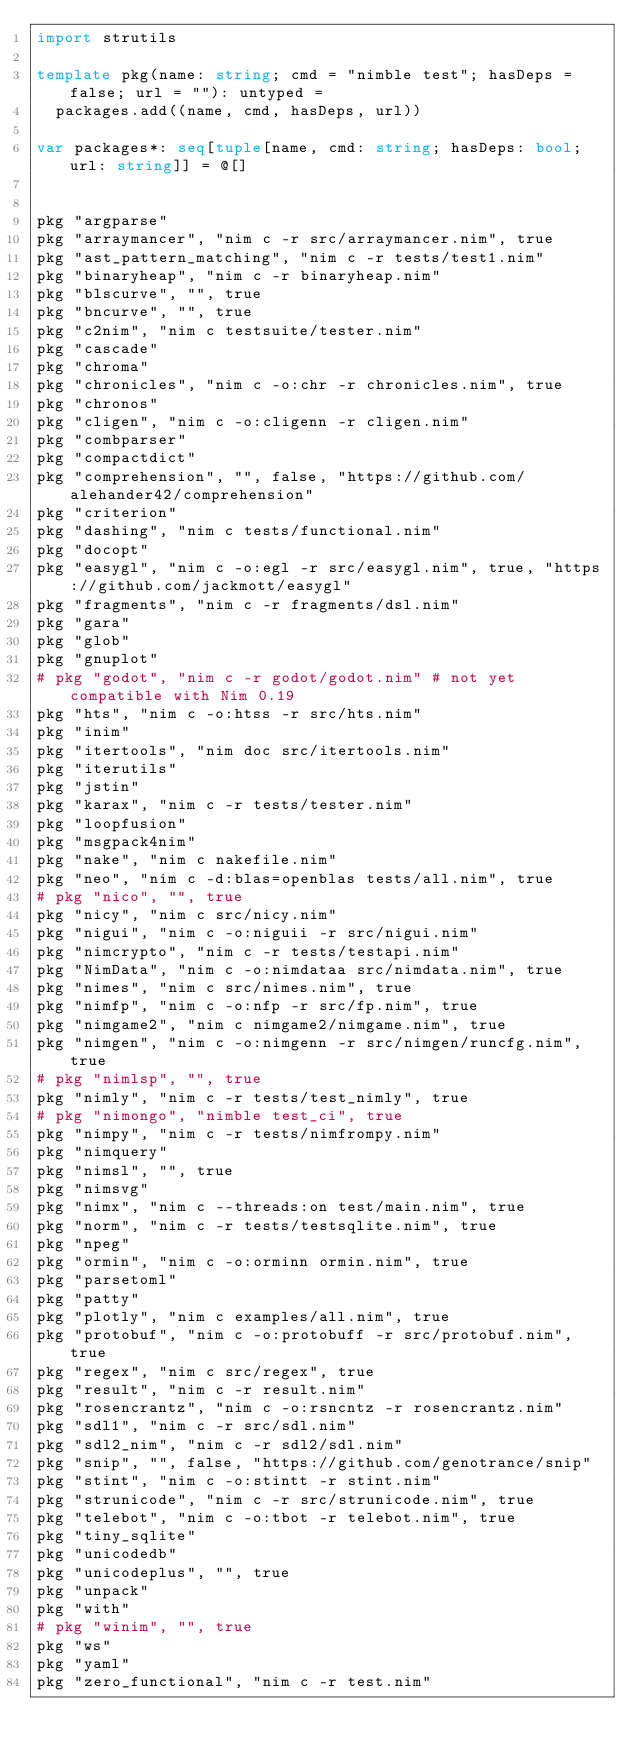<code> <loc_0><loc_0><loc_500><loc_500><_Nim_>import strutils

template pkg(name: string; cmd = "nimble test"; hasDeps = false; url = ""): untyped =
  packages.add((name, cmd, hasDeps, url))

var packages*: seq[tuple[name, cmd: string; hasDeps: bool; url: string]] = @[]


pkg "argparse"
pkg "arraymancer", "nim c -r src/arraymancer.nim", true
pkg "ast_pattern_matching", "nim c -r tests/test1.nim"
pkg "binaryheap", "nim c -r binaryheap.nim"
pkg "blscurve", "", true
pkg "bncurve", "", true
pkg "c2nim", "nim c testsuite/tester.nim"
pkg "cascade"
pkg "chroma"
pkg "chronicles", "nim c -o:chr -r chronicles.nim", true
pkg "chronos"
pkg "cligen", "nim c -o:cligenn -r cligen.nim"
pkg "combparser"
pkg "compactdict"
pkg "comprehension", "", false, "https://github.com/alehander42/comprehension"
pkg "criterion"
pkg "dashing", "nim c tests/functional.nim"
pkg "docopt"
pkg "easygl", "nim c -o:egl -r src/easygl.nim", true, "https://github.com/jackmott/easygl"
pkg "fragments", "nim c -r fragments/dsl.nim"
pkg "gara"
pkg "glob"
pkg "gnuplot"
# pkg "godot", "nim c -r godot/godot.nim" # not yet compatible with Nim 0.19
pkg "hts", "nim c -o:htss -r src/hts.nim"
pkg "inim"
pkg "itertools", "nim doc src/itertools.nim"
pkg "iterutils"
pkg "jstin"
pkg "karax", "nim c -r tests/tester.nim"
pkg "loopfusion"
pkg "msgpack4nim"
pkg "nake", "nim c nakefile.nim"
pkg "neo", "nim c -d:blas=openblas tests/all.nim", true
# pkg "nico", "", true
pkg "nicy", "nim c src/nicy.nim"
pkg "nigui", "nim c -o:niguii -r src/nigui.nim"
pkg "nimcrypto", "nim c -r tests/testapi.nim"
pkg "NimData", "nim c -o:nimdataa src/nimdata.nim", true
pkg "nimes", "nim c src/nimes.nim", true
pkg "nimfp", "nim c -o:nfp -r src/fp.nim", true
pkg "nimgame2", "nim c nimgame2/nimgame.nim", true
pkg "nimgen", "nim c -o:nimgenn -r src/nimgen/runcfg.nim", true
# pkg "nimlsp", "", true
pkg "nimly", "nim c -r tests/test_nimly", true
# pkg "nimongo", "nimble test_ci", true
pkg "nimpy", "nim c -r tests/nimfrompy.nim"
pkg "nimquery"
pkg "nimsl", "", true
pkg "nimsvg"
pkg "nimx", "nim c --threads:on test/main.nim", true
pkg "norm", "nim c -r tests/testsqlite.nim", true
pkg "npeg"
pkg "ormin", "nim c -o:orminn ormin.nim", true
pkg "parsetoml"
pkg "patty"
pkg "plotly", "nim c examples/all.nim", true
pkg "protobuf", "nim c -o:protobuff -r src/protobuf.nim", true
pkg "regex", "nim c src/regex", true
pkg "result", "nim c -r result.nim"
pkg "rosencrantz", "nim c -o:rsncntz -r rosencrantz.nim"
pkg "sdl1", "nim c -r src/sdl.nim"
pkg "sdl2_nim", "nim c -r sdl2/sdl.nim"
pkg "snip", "", false, "https://github.com/genotrance/snip"
pkg "stint", "nim c -o:stintt -r stint.nim"
pkg "strunicode", "nim c -r src/strunicode.nim", true
pkg "telebot", "nim c -o:tbot -r telebot.nim", true
pkg "tiny_sqlite"
pkg "unicodedb"
pkg "unicodeplus", "", true
pkg "unpack"
pkg "with"
# pkg "winim", "", true
pkg "ws"
pkg "yaml"
pkg "zero_functional", "nim c -r test.nim"
</code> 